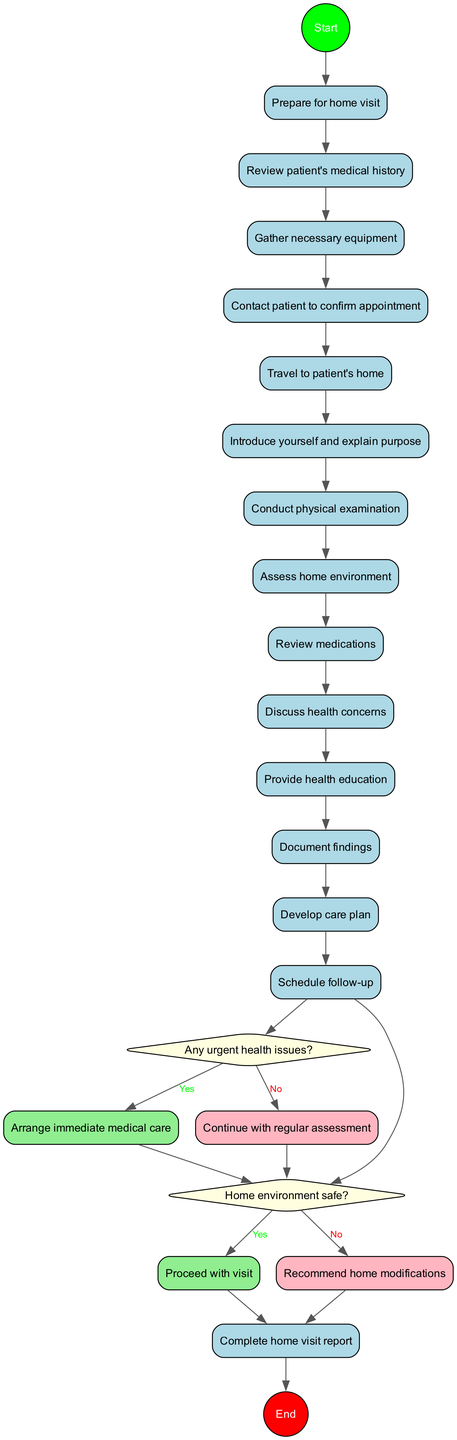What is the first activity for medical students in the diagram? The start node leads directly to the first activity, which is labeled as "Prepare for home visit." This can be easily identified as the initial step after starting the process.
Answer: Prepare for home visit How many activities are listed in the diagram? Counting the activities provided in the data section, there are a total of 12 activities that medical students should follow during the home visit.
Answer: 12 What is the decision point after the physical examination? The activity directly following the physical examination is the question, "Any urgent health issues?" This is a critical decision point that affects the next steps in the visit.
Answer: Any urgent health issues? What happens if the answer is "yes" to the question about urgent health issues? If the answer to "Any urgent health issues?" is "yes," the flow directs the medical student to "Arrange immediate medical care," which is the required action in response to a critical situation.
Answer: Arrange immediate medical care What indicates that the home environment is safe? The question "Home environment safe?" is a decision point, and if the answer is "yes," it allows the student to "Proceed with visit." This reflects a positive assessment of the patient's safety at home.
Answer: Proceed with visit What is the final step in the diagram after all activities? The last node reached in the process is labeled "Complete home visit report," indicating that after all assessments and procedures, documenting findings is the final requirement.
Answer: Complete home visit report How many decision points are included in the diagram? There are two decision points illustrated in the diagram, each represented by a diamond shape including the questions regarding urgent health issues and home safety.
Answer: 2 If a student's assessment finds the home environment unsafe, what action should be taken? If the response to "Home environment safe?" is "no," the next action is to "Recommend home modifications," focusing on improving safety for the patient.
Answer: Recommend home modifications What is the purpose of conducting a home visit, as indicated in the diagram? Throughout the activities listed, the overarching purpose of the home visit is to assess the patient's health, providing documentation and care planning as indicated by actions like "Conduct physical examination" and "Discuss health concerns."
Answer: Assess patient's health 